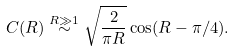Convert formula to latex. <formula><loc_0><loc_0><loc_500><loc_500>C ( R ) \stackrel { R \gg 1 } { \sim } \sqrt { \frac { 2 } { \pi R } } \cos ( R - \pi / 4 ) .</formula> 